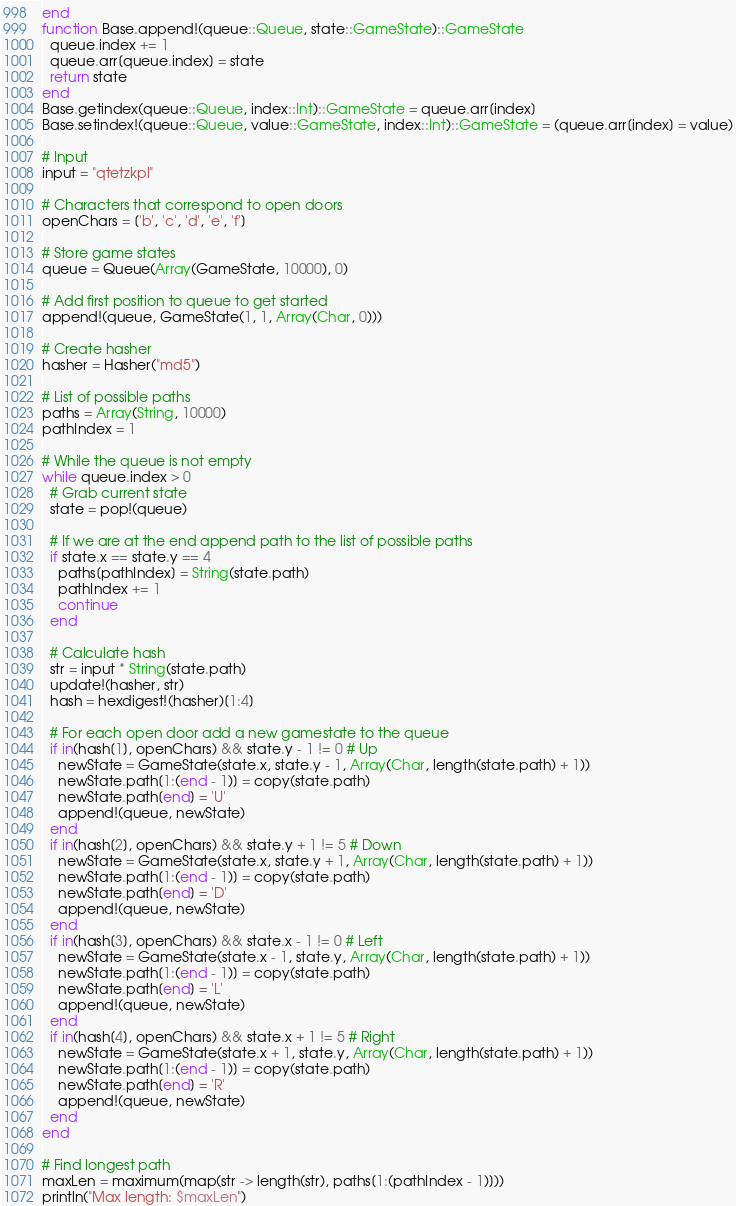<code> <loc_0><loc_0><loc_500><loc_500><_Julia_>end
function Base.append!(queue::Queue, state::GameState)::GameState
  queue.index += 1
  queue.arr[queue.index] = state
  return state
end
Base.getindex(queue::Queue, index::Int)::GameState = queue.arr[index]
Base.setindex!(queue::Queue, value::GameState, index::Int)::GameState = (queue.arr[index] = value)

# Input
input = "qtetzkpl"

# Characters that correspond to open doors
openChars = ['b', 'c', 'd', 'e', 'f']

# Store game states
queue = Queue(Array(GameState, 10000), 0)

# Add first position to queue to get started
append!(queue, GameState(1, 1, Array(Char, 0)))

# Create hasher
hasher = Hasher("md5")

# List of possible paths
paths = Array(String, 10000)
pathIndex = 1

# While the queue is not empty
while queue.index > 0
  # Grab current state
  state = pop!(queue)

  # If we are at the end append path to the list of possible paths
  if state.x == state.y == 4
    paths[pathIndex] = String(state.path)
    pathIndex += 1
    continue
  end

  # Calculate hash
  str = input * String(state.path)
  update!(hasher, str)
  hash = hexdigest!(hasher)[1:4]

  # For each open door add a new gamestate to the queue
  if in(hash[1], openChars) && state.y - 1 != 0 # Up
    newState = GameState(state.x, state.y - 1, Array(Char, length(state.path) + 1))
    newState.path[1:(end - 1)] = copy(state.path)
    newState.path[end] = 'U'
    append!(queue, newState)
  end
  if in(hash[2], openChars) && state.y + 1 != 5 # Down
    newState = GameState(state.x, state.y + 1, Array(Char, length(state.path) + 1))
    newState.path[1:(end - 1)] = copy(state.path)
    newState.path[end] = 'D'
    append!(queue, newState)
  end
  if in(hash[3], openChars) && state.x - 1 != 0 # Left
    newState = GameState(state.x - 1, state.y, Array(Char, length(state.path) + 1))
    newState.path[1:(end - 1)] = copy(state.path)
    newState.path[end] = 'L'
    append!(queue, newState)
  end
  if in(hash[4], openChars) && state.x + 1 != 5 # Right
    newState = GameState(state.x + 1, state.y, Array(Char, length(state.path) + 1))
    newState.path[1:(end - 1)] = copy(state.path)
    newState.path[end] = 'R'
    append!(queue, newState)
  end
end

# Find longest path
maxLen = maximum(map(str -> length(str), paths[1:(pathIndex - 1)]))
println("Max length: $maxLen")
</code> 